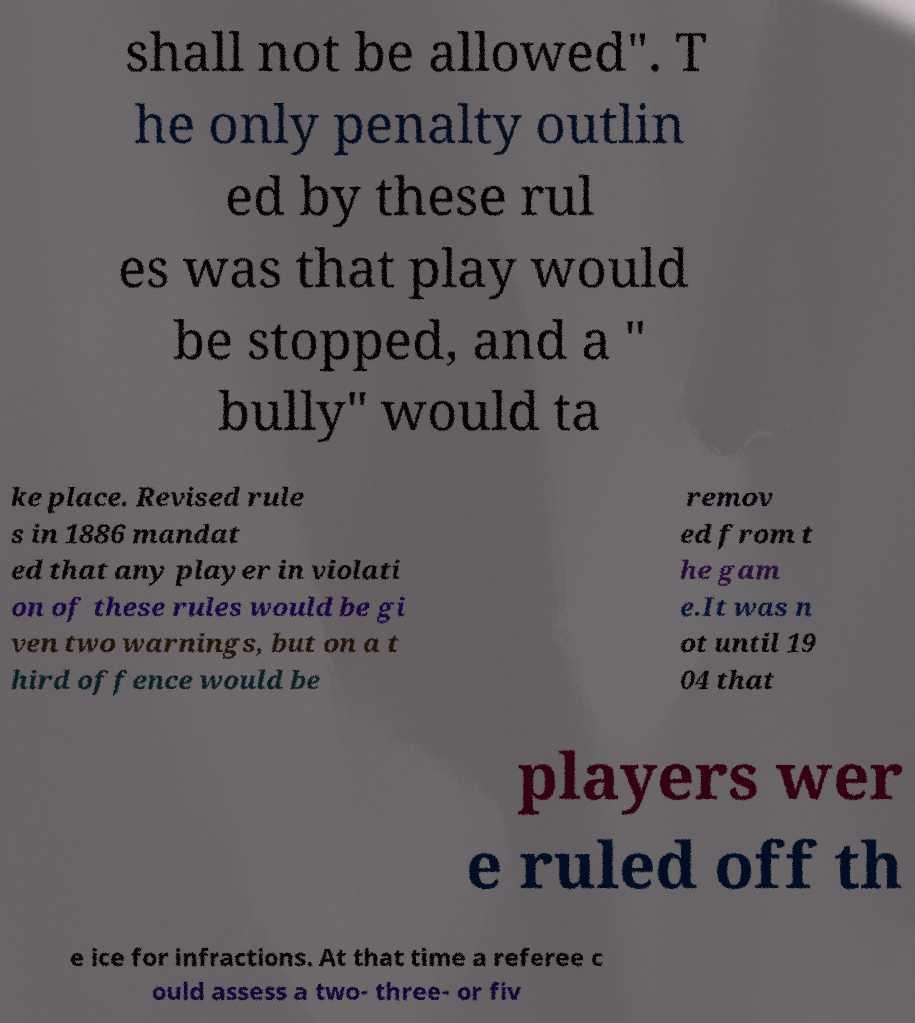Can you accurately transcribe the text from the provided image for me? shall not be allowed". T he only penalty outlin ed by these rul es was that play would be stopped, and a " bully" would ta ke place. Revised rule s in 1886 mandat ed that any player in violati on of these rules would be gi ven two warnings, but on a t hird offence would be remov ed from t he gam e.It was n ot until 19 04 that players wer e ruled off th e ice for infractions. At that time a referee c ould assess a two- three- or fiv 